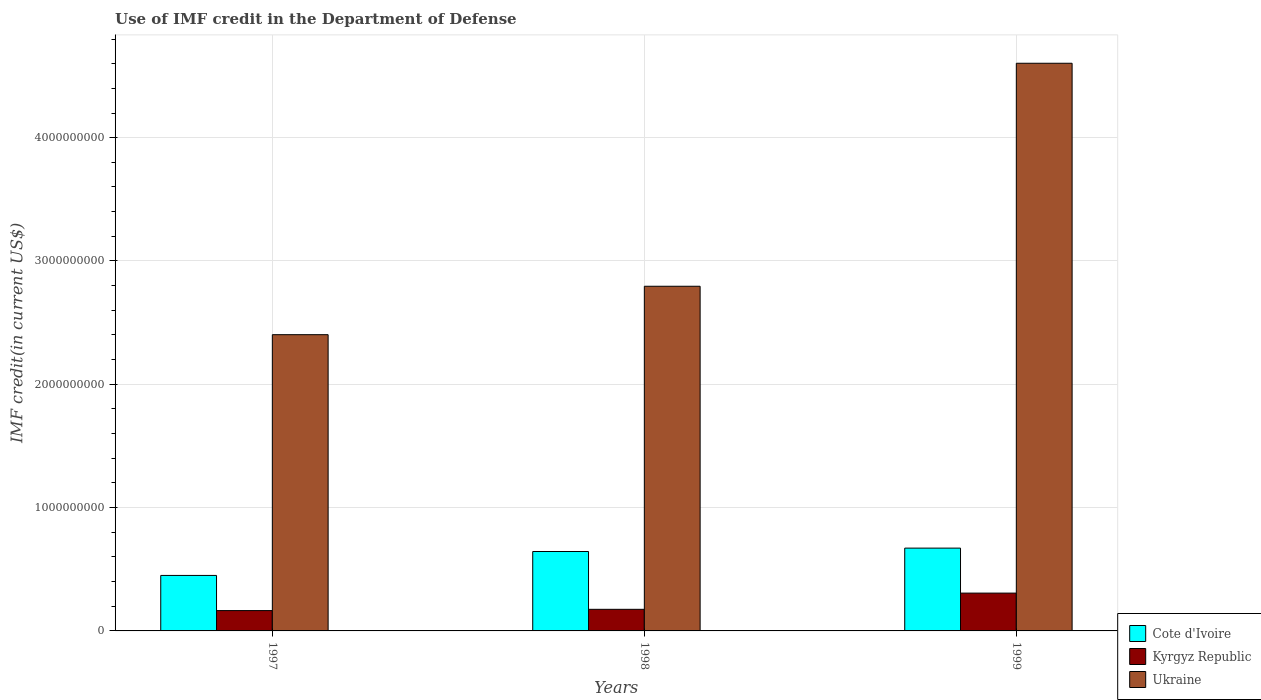How many groups of bars are there?
Offer a very short reply. 3. What is the IMF credit in the Department of Defense in Cote d'Ivoire in 1999?
Offer a very short reply. 6.71e+08. Across all years, what is the maximum IMF credit in the Department of Defense in Ukraine?
Provide a short and direct response. 4.60e+09. Across all years, what is the minimum IMF credit in the Department of Defense in Ukraine?
Offer a terse response. 2.40e+09. What is the total IMF credit in the Department of Defense in Ukraine in the graph?
Your answer should be compact. 9.80e+09. What is the difference between the IMF credit in the Department of Defense in Kyrgyz Republic in 1998 and that in 1999?
Give a very brief answer. -1.31e+08. What is the difference between the IMF credit in the Department of Defense in Cote d'Ivoire in 1997 and the IMF credit in the Department of Defense in Kyrgyz Republic in 1998?
Offer a terse response. 2.75e+08. What is the average IMF credit in the Department of Defense in Ukraine per year?
Provide a short and direct response. 3.27e+09. In the year 1997, what is the difference between the IMF credit in the Department of Defense in Ukraine and IMF credit in the Department of Defense in Cote d'Ivoire?
Your response must be concise. 1.95e+09. What is the ratio of the IMF credit in the Department of Defense in Kyrgyz Republic in 1998 to that in 1999?
Provide a short and direct response. 0.57. Is the difference between the IMF credit in the Department of Defense in Ukraine in 1998 and 1999 greater than the difference between the IMF credit in the Department of Defense in Cote d'Ivoire in 1998 and 1999?
Provide a short and direct response. No. What is the difference between the highest and the second highest IMF credit in the Department of Defense in Cote d'Ivoire?
Your response must be concise. 2.75e+07. What is the difference between the highest and the lowest IMF credit in the Department of Defense in Ukraine?
Provide a succinct answer. 2.20e+09. What does the 2nd bar from the left in 1998 represents?
Offer a terse response. Kyrgyz Republic. What does the 2nd bar from the right in 1999 represents?
Make the answer very short. Kyrgyz Republic. Is it the case that in every year, the sum of the IMF credit in the Department of Defense in Kyrgyz Republic and IMF credit in the Department of Defense in Ukraine is greater than the IMF credit in the Department of Defense in Cote d'Ivoire?
Offer a terse response. Yes. Does the graph contain grids?
Offer a terse response. Yes. Where does the legend appear in the graph?
Your answer should be compact. Bottom right. How many legend labels are there?
Offer a very short reply. 3. What is the title of the graph?
Provide a succinct answer. Use of IMF credit in the Department of Defense. What is the label or title of the X-axis?
Provide a succinct answer. Years. What is the label or title of the Y-axis?
Your answer should be compact. IMF credit(in current US$). What is the IMF credit(in current US$) in Cote d'Ivoire in 1997?
Make the answer very short. 4.50e+08. What is the IMF credit(in current US$) of Kyrgyz Republic in 1997?
Ensure brevity in your answer.  1.65e+08. What is the IMF credit(in current US$) of Ukraine in 1997?
Provide a succinct answer. 2.40e+09. What is the IMF credit(in current US$) in Cote d'Ivoire in 1998?
Offer a terse response. 6.44e+08. What is the IMF credit(in current US$) of Kyrgyz Republic in 1998?
Provide a succinct answer. 1.75e+08. What is the IMF credit(in current US$) in Ukraine in 1998?
Offer a very short reply. 2.80e+09. What is the IMF credit(in current US$) of Cote d'Ivoire in 1999?
Make the answer very short. 6.71e+08. What is the IMF credit(in current US$) in Kyrgyz Republic in 1999?
Ensure brevity in your answer.  3.07e+08. What is the IMF credit(in current US$) in Ukraine in 1999?
Your answer should be compact. 4.60e+09. Across all years, what is the maximum IMF credit(in current US$) of Cote d'Ivoire?
Offer a very short reply. 6.71e+08. Across all years, what is the maximum IMF credit(in current US$) of Kyrgyz Republic?
Make the answer very short. 3.07e+08. Across all years, what is the maximum IMF credit(in current US$) of Ukraine?
Keep it short and to the point. 4.60e+09. Across all years, what is the minimum IMF credit(in current US$) of Cote d'Ivoire?
Provide a short and direct response. 4.50e+08. Across all years, what is the minimum IMF credit(in current US$) of Kyrgyz Republic?
Your answer should be very brief. 1.65e+08. Across all years, what is the minimum IMF credit(in current US$) of Ukraine?
Provide a succinct answer. 2.40e+09. What is the total IMF credit(in current US$) of Cote d'Ivoire in the graph?
Ensure brevity in your answer.  1.77e+09. What is the total IMF credit(in current US$) of Kyrgyz Republic in the graph?
Your answer should be very brief. 6.47e+08. What is the total IMF credit(in current US$) in Ukraine in the graph?
Keep it short and to the point. 9.80e+09. What is the difference between the IMF credit(in current US$) of Cote d'Ivoire in 1997 and that in 1998?
Your answer should be very brief. -1.94e+08. What is the difference between the IMF credit(in current US$) of Kyrgyz Republic in 1997 and that in 1998?
Your answer should be compact. -1.03e+07. What is the difference between the IMF credit(in current US$) of Ukraine in 1997 and that in 1998?
Offer a terse response. -3.93e+08. What is the difference between the IMF credit(in current US$) in Cote d'Ivoire in 1997 and that in 1999?
Provide a succinct answer. -2.22e+08. What is the difference between the IMF credit(in current US$) in Kyrgyz Republic in 1997 and that in 1999?
Ensure brevity in your answer.  -1.42e+08. What is the difference between the IMF credit(in current US$) of Ukraine in 1997 and that in 1999?
Your response must be concise. -2.20e+09. What is the difference between the IMF credit(in current US$) of Cote d'Ivoire in 1998 and that in 1999?
Offer a terse response. -2.75e+07. What is the difference between the IMF credit(in current US$) of Kyrgyz Republic in 1998 and that in 1999?
Your answer should be compact. -1.31e+08. What is the difference between the IMF credit(in current US$) in Ukraine in 1998 and that in 1999?
Offer a very short reply. -1.81e+09. What is the difference between the IMF credit(in current US$) of Cote d'Ivoire in 1997 and the IMF credit(in current US$) of Kyrgyz Republic in 1998?
Offer a very short reply. 2.75e+08. What is the difference between the IMF credit(in current US$) in Cote d'Ivoire in 1997 and the IMF credit(in current US$) in Ukraine in 1998?
Your answer should be compact. -2.35e+09. What is the difference between the IMF credit(in current US$) in Kyrgyz Republic in 1997 and the IMF credit(in current US$) in Ukraine in 1998?
Your answer should be compact. -2.63e+09. What is the difference between the IMF credit(in current US$) of Cote d'Ivoire in 1997 and the IMF credit(in current US$) of Kyrgyz Republic in 1999?
Provide a succinct answer. 1.43e+08. What is the difference between the IMF credit(in current US$) in Cote d'Ivoire in 1997 and the IMF credit(in current US$) in Ukraine in 1999?
Ensure brevity in your answer.  -4.15e+09. What is the difference between the IMF credit(in current US$) in Kyrgyz Republic in 1997 and the IMF credit(in current US$) in Ukraine in 1999?
Your answer should be very brief. -4.44e+09. What is the difference between the IMF credit(in current US$) of Cote d'Ivoire in 1998 and the IMF credit(in current US$) of Kyrgyz Republic in 1999?
Offer a very short reply. 3.37e+08. What is the difference between the IMF credit(in current US$) of Cote d'Ivoire in 1998 and the IMF credit(in current US$) of Ukraine in 1999?
Give a very brief answer. -3.96e+09. What is the difference between the IMF credit(in current US$) of Kyrgyz Republic in 1998 and the IMF credit(in current US$) of Ukraine in 1999?
Keep it short and to the point. -4.43e+09. What is the average IMF credit(in current US$) in Cote d'Ivoire per year?
Give a very brief answer. 5.88e+08. What is the average IMF credit(in current US$) of Kyrgyz Republic per year?
Offer a terse response. 2.16e+08. What is the average IMF credit(in current US$) in Ukraine per year?
Keep it short and to the point. 3.27e+09. In the year 1997, what is the difference between the IMF credit(in current US$) in Cote d'Ivoire and IMF credit(in current US$) in Kyrgyz Republic?
Give a very brief answer. 2.85e+08. In the year 1997, what is the difference between the IMF credit(in current US$) in Cote d'Ivoire and IMF credit(in current US$) in Ukraine?
Your answer should be very brief. -1.95e+09. In the year 1997, what is the difference between the IMF credit(in current US$) in Kyrgyz Republic and IMF credit(in current US$) in Ukraine?
Give a very brief answer. -2.24e+09. In the year 1998, what is the difference between the IMF credit(in current US$) of Cote d'Ivoire and IMF credit(in current US$) of Kyrgyz Republic?
Your answer should be compact. 4.69e+08. In the year 1998, what is the difference between the IMF credit(in current US$) in Cote d'Ivoire and IMF credit(in current US$) in Ukraine?
Your answer should be compact. -2.15e+09. In the year 1998, what is the difference between the IMF credit(in current US$) in Kyrgyz Republic and IMF credit(in current US$) in Ukraine?
Make the answer very short. -2.62e+09. In the year 1999, what is the difference between the IMF credit(in current US$) of Cote d'Ivoire and IMF credit(in current US$) of Kyrgyz Republic?
Give a very brief answer. 3.65e+08. In the year 1999, what is the difference between the IMF credit(in current US$) of Cote d'Ivoire and IMF credit(in current US$) of Ukraine?
Keep it short and to the point. -3.93e+09. In the year 1999, what is the difference between the IMF credit(in current US$) in Kyrgyz Republic and IMF credit(in current US$) in Ukraine?
Ensure brevity in your answer.  -4.30e+09. What is the ratio of the IMF credit(in current US$) in Cote d'Ivoire in 1997 to that in 1998?
Provide a short and direct response. 0.7. What is the ratio of the IMF credit(in current US$) in Kyrgyz Republic in 1997 to that in 1998?
Provide a short and direct response. 0.94. What is the ratio of the IMF credit(in current US$) of Ukraine in 1997 to that in 1998?
Ensure brevity in your answer.  0.86. What is the ratio of the IMF credit(in current US$) in Cote d'Ivoire in 1997 to that in 1999?
Offer a very short reply. 0.67. What is the ratio of the IMF credit(in current US$) of Kyrgyz Republic in 1997 to that in 1999?
Make the answer very short. 0.54. What is the ratio of the IMF credit(in current US$) of Ukraine in 1997 to that in 1999?
Provide a short and direct response. 0.52. What is the ratio of the IMF credit(in current US$) in Cote d'Ivoire in 1998 to that in 1999?
Your answer should be compact. 0.96. What is the ratio of the IMF credit(in current US$) in Kyrgyz Republic in 1998 to that in 1999?
Give a very brief answer. 0.57. What is the ratio of the IMF credit(in current US$) of Ukraine in 1998 to that in 1999?
Your answer should be very brief. 0.61. What is the difference between the highest and the second highest IMF credit(in current US$) in Cote d'Ivoire?
Offer a very short reply. 2.75e+07. What is the difference between the highest and the second highest IMF credit(in current US$) of Kyrgyz Republic?
Your answer should be very brief. 1.31e+08. What is the difference between the highest and the second highest IMF credit(in current US$) in Ukraine?
Give a very brief answer. 1.81e+09. What is the difference between the highest and the lowest IMF credit(in current US$) in Cote d'Ivoire?
Your answer should be compact. 2.22e+08. What is the difference between the highest and the lowest IMF credit(in current US$) in Kyrgyz Republic?
Give a very brief answer. 1.42e+08. What is the difference between the highest and the lowest IMF credit(in current US$) in Ukraine?
Ensure brevity in your answer.  2.20e+09. 